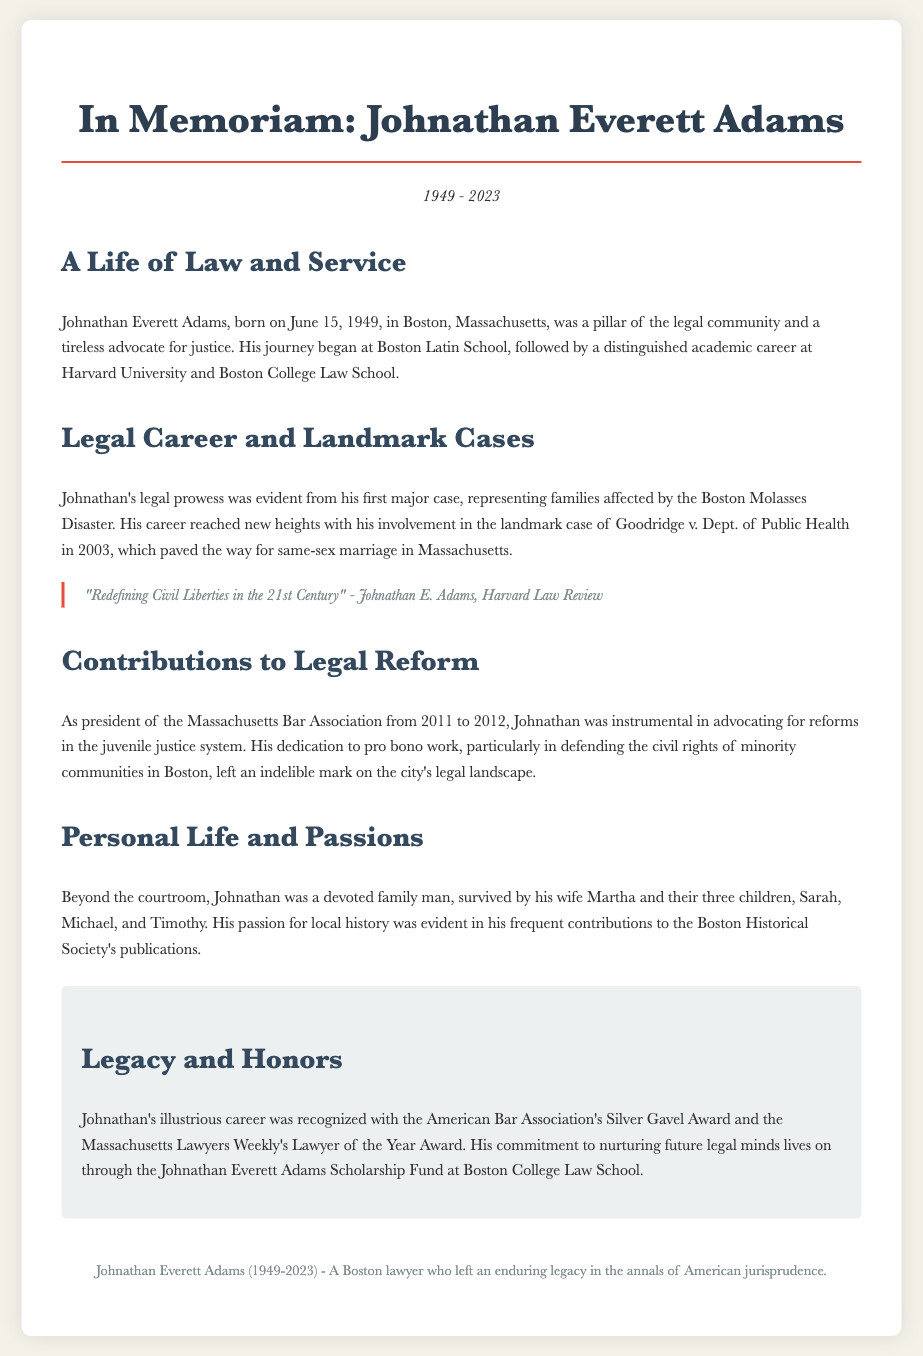What year was Johnathan Everett Adams born? The document states his birth year clearly.
Answer: 1949 What significant case did Johnathan Adams work on in 2003? The document specifically mentions his role in a landmark case.
Answer: Goodridge v. Dept. of Public Health How long did Johnathan serve as president of the Massachusetts Bar Association? The document provides the year spans of his presidency.
Answer: 2011 to 2012 What award did Johnathan receive from the American Bar Association? The document lists his accomplishments and recognitions.
Answer: Silver Gavel Award How many children did Johnathan have? The document provides information about his family.
Answer: Three What was Johnathan's involvement with the Boston Historical Society? The document mentions his contributions related to local history.
Answer: Frequent contributions What is the name of the scholarship fund established in Johnathan's honor? The document states the purpose and naming of the fund.
Answer: Johnathan Everett Adams Scholarship Fund In what area did Johnathan advocate for reforms during his presidency? The document specifies the focus of his advocacy work.
Answer: Juvenile justice system What is the full name of the lawyer being remembered in the obituary? The title of the obituary specifies his full name.
Answer: Johnathan Everett Adams 